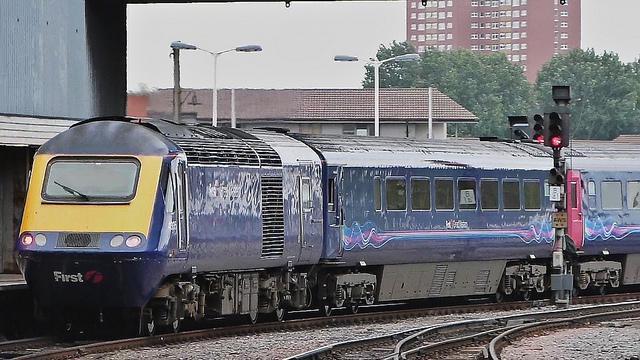How many skis are visible?
Give a very brief answer. 0. 